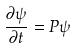Convert formula to latex. <formula><loc_0><loc_0><loc_500><loc_500>\frac { \partial \psi } { \partial t } = P \psi</formula> 